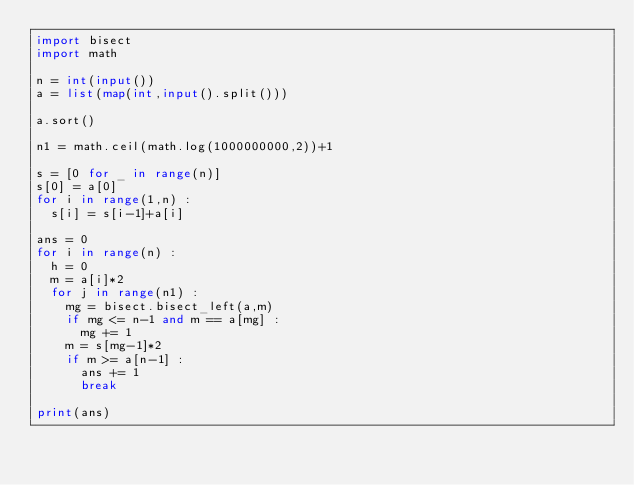<code> <loc_0><loc_0><loc_500><loc_500><_Python_>import bisect
import math

n = int(input())
a = list(map(int,input().split()))

a.sort()

n1 = math.ceil(math.log(1000000000,2))+1

s = [0 for _ in range(n)]
s[0] = a[0]
for i in range(1,n) :
  s[i] = s[i-1]+a[i]

ans = 0
for i in range(n) :
  h = 0
  m = a[i]*2
  for j in range(n1) :
    mg = bisect.bisect_left(a,m)
    if mg <= n-1 and m == a[mg] :
      mg += 1
    m = s[mg-1]*2
    if m >= a[n-1] :
      ans += 1
      break
  
print(ans)</code> 